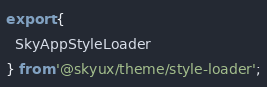<code> <loc_0><loc_0><loc_500><loc_500><_TypeScript_>export {
  SkyAppStyleLoader
} from '@skyux/theme/style-loader';
</code> 